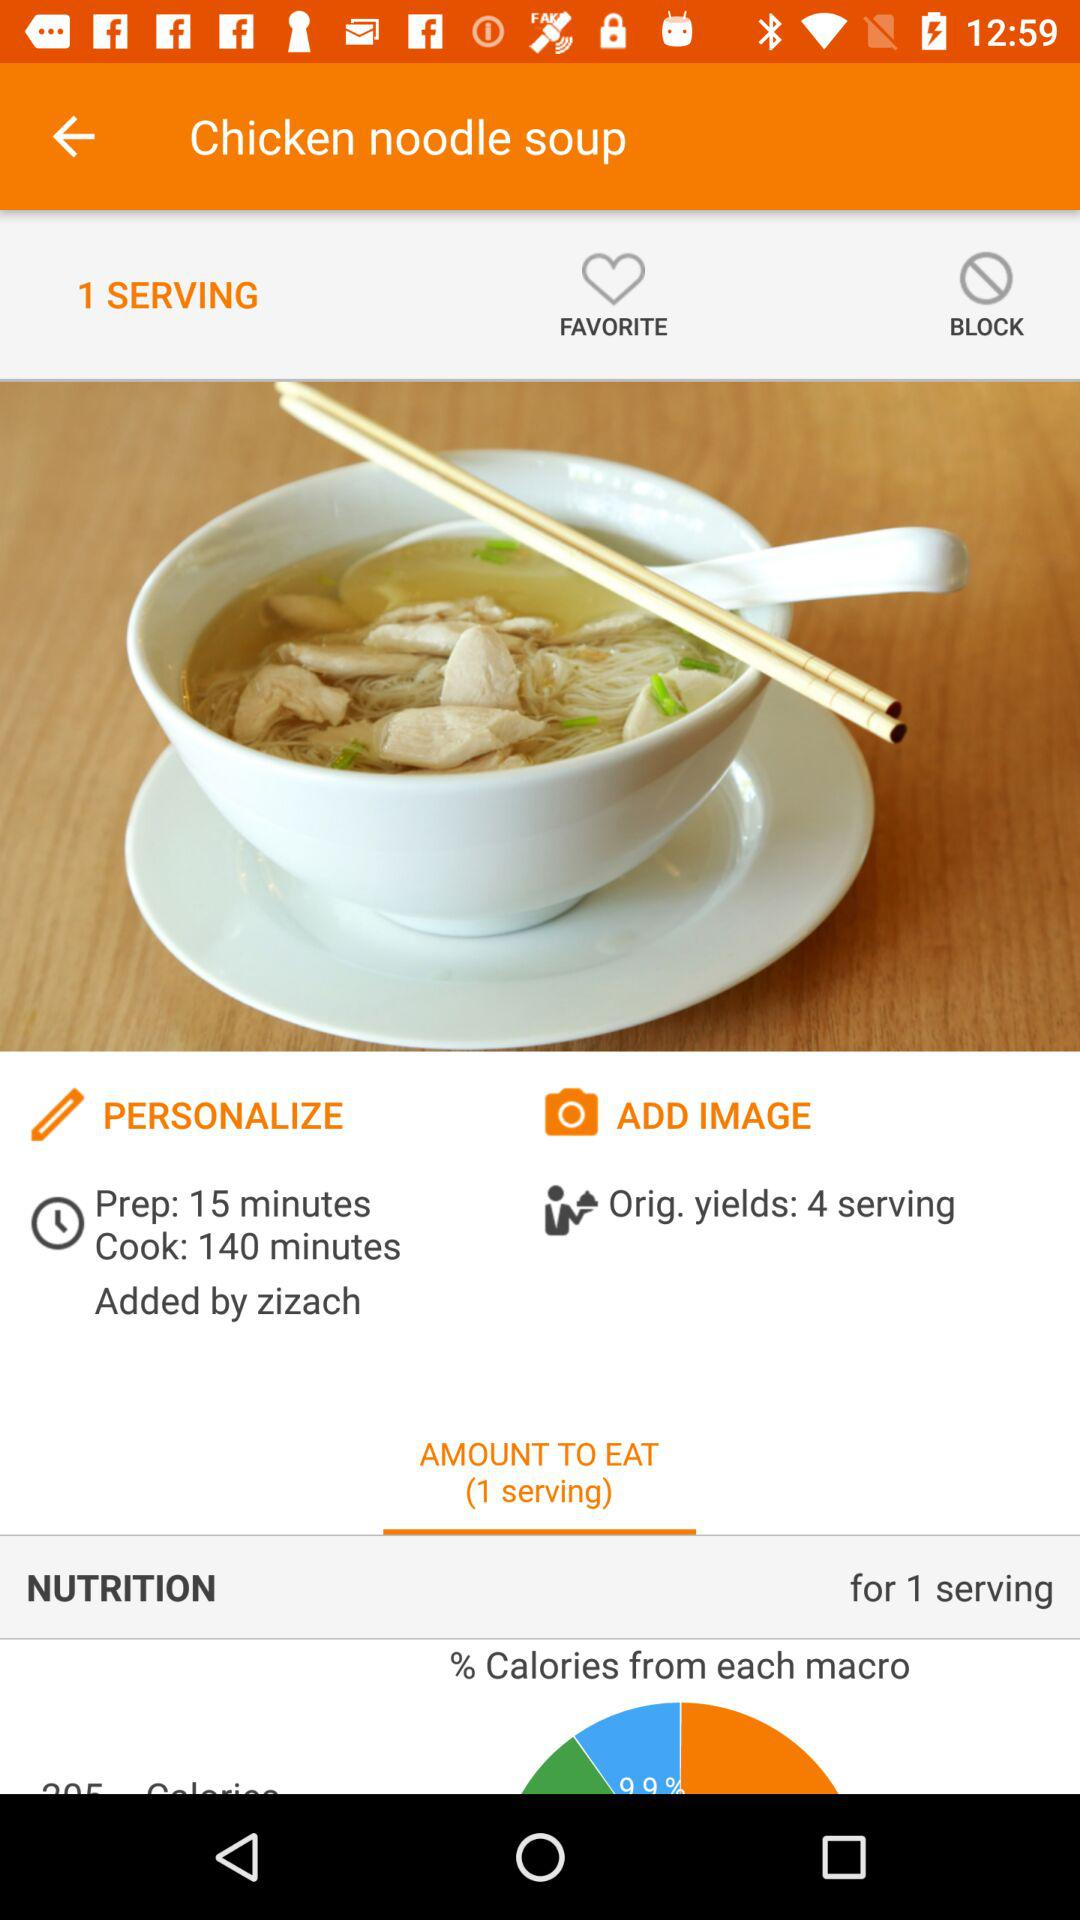How many people can be served from the original yield? The number of people that can be served from the original yield is 4. 